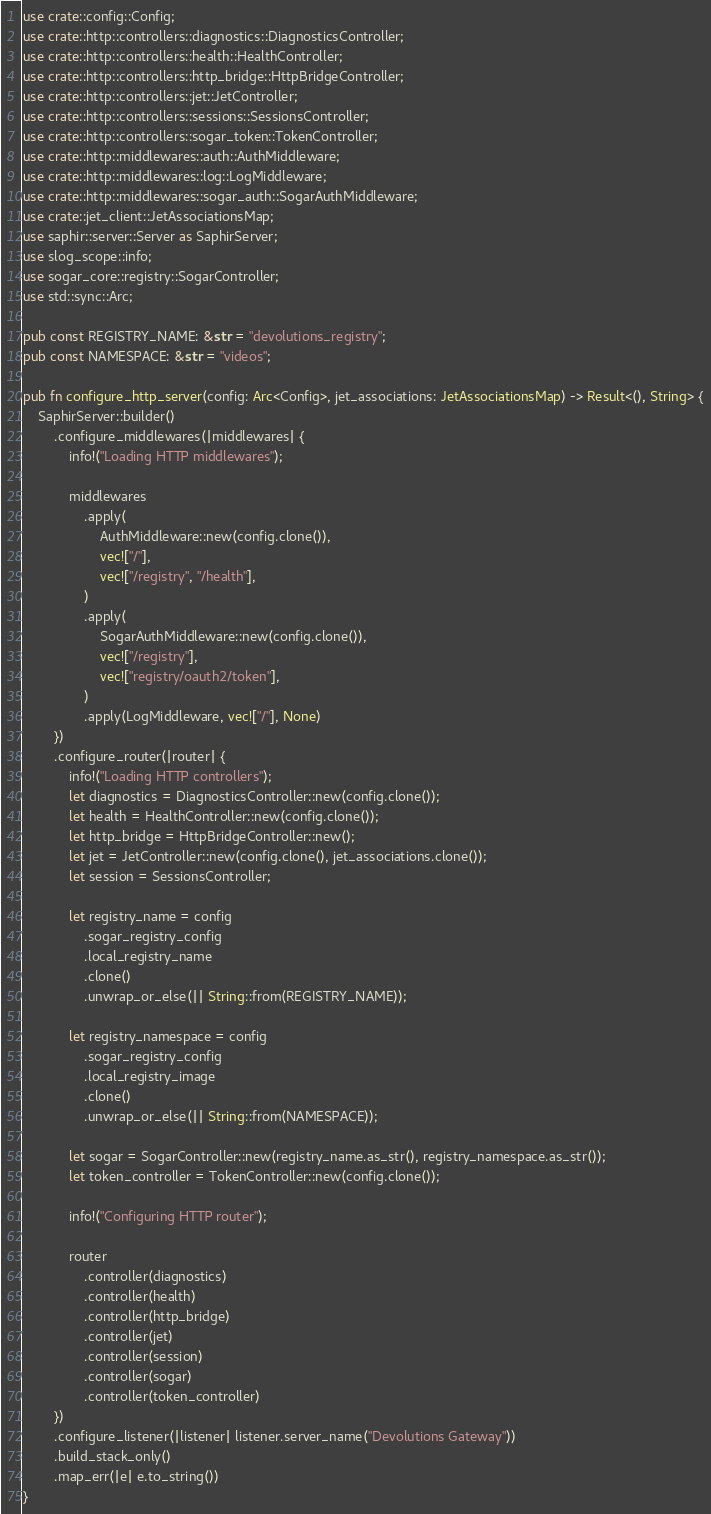Convert code to text. <code><loc_0><loc_0><loc_500><loc_500><_Rust_>use crate::config::Config;
use crate::http::controllers::diagnostics::DiagnosticsController;
use crate::http::controllers::health::HealthController;
use crate::http::controllers::http_bridge::HttpBridgeController;
use crate::http::controllers::jet::JetController;
use crate::http::controllers::sessions::SessionsController;
use crate::http::controllers::sogar_token::TokenController;
use crate::http::middlewares::auth::AuthMiddleware;
use crate::http::middlewares::log::LogMiddleware;
use crate::http::middlewares::sogar_auth::SogarAuthMiddleware;
use crate::jet_client::JetAssociationsMap;
use saphir::server::Server as SaphirServer;
use slog_scope::info;
use sogar_core::registry::SogarController;
use std::sync::Arc;

pub const REGISTRY_NAME: &str = "devolutions_registry";
pub const NAMESPACE: &str = "videos";

pub fn configure_http_server(config: Arc<Config>, jet_associations: JetAssociationsMap) -> Result<(), String> {
    SaphirServer::builder()
        .configure_middlewares(|middlewares| {
            info!("Loading HTTP middlewares");

            middlewares
                .apply(
                    AuthMiddleware::new(config.clone()),
                    vec!["/"],
                    vec!["/registry", "/health"],
                )
                .apply(
                    SogarAuthMiddleware::new(config.clone()),
                    vec!["/registry"],
                    vec!["registry/oauth2/token"],
                )
                .apply(LogMiddleware, vec!["/"], None)
        })
        .configure_router(|router| {
            info!("Loading HTTP controllers");
            let diagnostics = DiagnosticsController::new(config.clone());
            let health = HealthController::new(config.clone());
            let http_bridge = HttpBridgeController::new();
            let jet = JetController::new(config.clone(), jet_associations.clone());
            let session = SessionsController;

            let registry_name = config
                .sogar_registry_config
                .local_registry_name
                .clone()
                .unwrap_or_else(|| String::from(REGISTRY_NAME));

            let registry_namespace = config
                .sogar_registry_config
                .local_registry_image
                .clone()
                .unwrap_or_else(|| String::from(NAMESPACE));

            let sogar = SogarController::new(registry_name.as_str(), registry_namespace.as_str());
            let token_controller = TokenController::new(config.clone());

            info!("Configuring HTTP router");

            router
                .controller(diagnostics)
                .controller(health)
                .controller(http_bridge)
                .controller(jet)
                .controller(session)
                .controller(sogar)
                .controller(token_controller)
        })
        .configure_listener(|listener| listener.server_name("Devolutions Gateway"))
        .build_stack_only()
        .map_err(|e| e.to_string())
}
</code> 